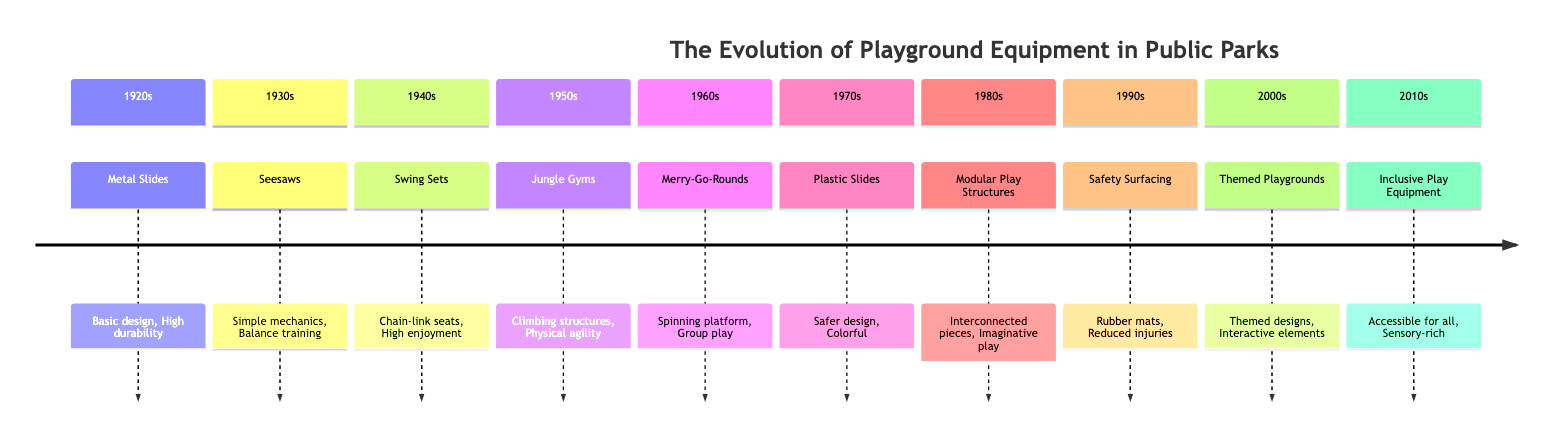What playground equipment was introduced in the 1920s? Referring to the timeline, the section for the 1920s states that "Metal Slides" were introduced as the playground equipment during this decade.
Answer: Metal Slides How many types of playground equipment are listed in the timeline? By counting the distinct sections provided in the timeline, there are a total of 10 different types of playground equipment mentioned, each corresponding to a decade.
Answer: 10 Which decade features "Safety Surfacing"? The section dedicated to the 1990s specifies "Safety Surfacing" as the type of playground equipment introduced during this period.
Answer: 1990s What is the key feature of "Inclusive Play Equipment"? The description under the 2010s states that the key feature of "Inclusive Play Equipment" is that it is "Accessible for all".
Answer: Accessible for all What change occurred in playground equipment from the 1940s to the 1950s? Comparing the sections, the transition from the 1940s, which had "Swing Sets," to the 1950s, which introduced "Jungle Gyms," indicates a shift from swinging to climbing structures, emphasizing physical agility.
Answer: Climbing structures Which decade is characterized by "Interconnected pieces"? The answer is found under the 1980s section where "Modular Play Structures" were described as having "Interconnected pieces".
Answer: 1980s What type of playground equipment became popular in the 2000s? According to the timeline, "Themed Playgrounds" are noted as the prevalent type of equipment introduced in the 2000s.
Answer: Themed Playgrounds Which decade's playground equipment promotes group play? By looking at the section for the 1960s, "Merry-Go-Rounds" are identified as the equipment that encourages group play.
Answer: Merry-Go-Rounds What was the main innovation in playground design in the 1970s? The 1970s section mentions "Plastic Slides" as a significant innovation, highlighting their safer design and colorful appearance.
Answer: Plastic Slides 